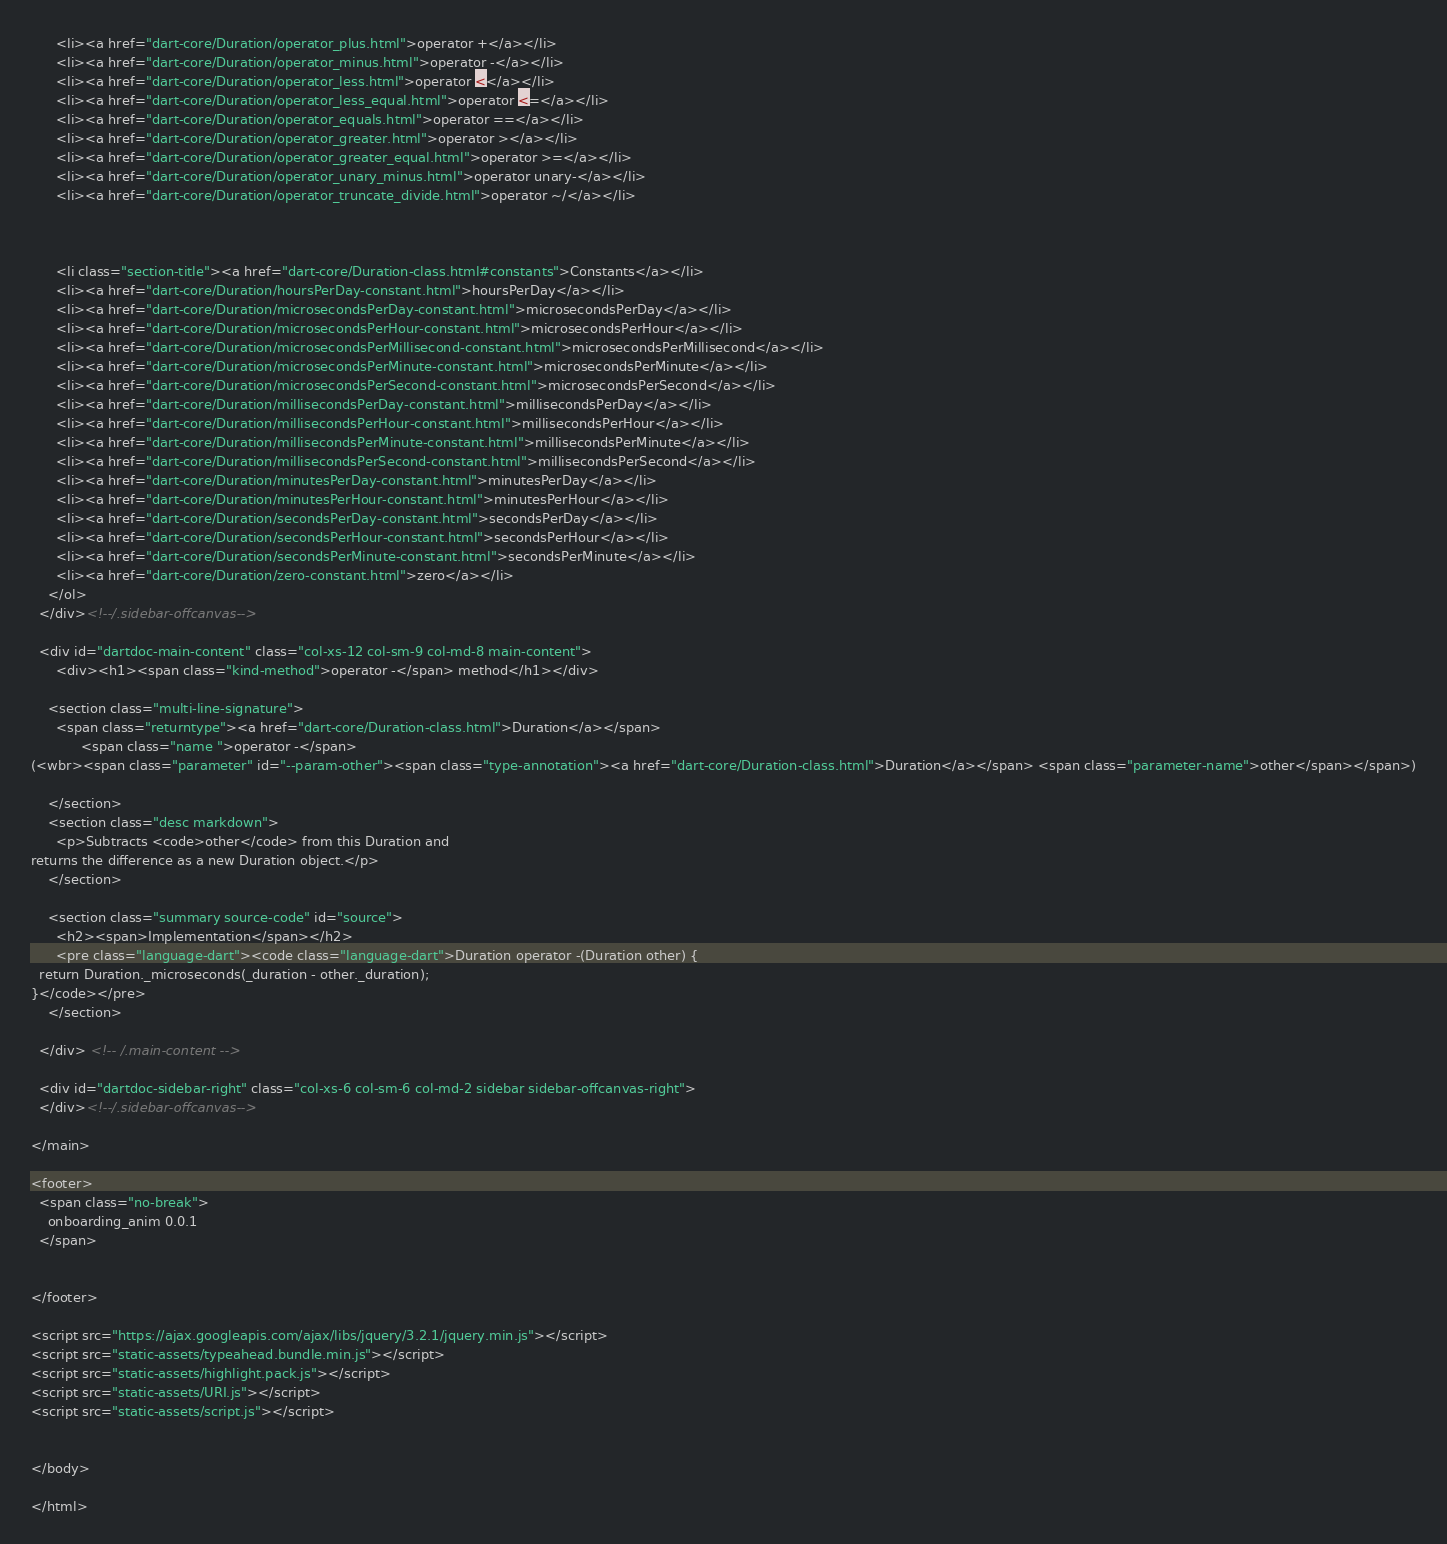<code> <loc_0><loc_0><loc_500><loc_500><_HTML_>      <li><a href="dart-core/Duration/operator_plus.html">operator +</a></li>
      <li><a href="dart-core/Duration/operator_minus.html">operator -</a></li>
      <li><a href="dart-core/Duration/operator_less.html">operator <</a></li>
      <li><a href="dart-core/Duration/operator_less_equal.html">operator <=</a></li>
      <li><a href="dart-core/Duration/operator_equals.html">operator ==</a></li>
      <li><a href="dart-core/Duration/operator_greater.html">operator ></a></li>
      <li><a href="dart-core/Duration/operator_greater_equal.html">operator >=</a></li>
      <li><a href="dart-core/Duration/operator_unary_minus.html">operator unary-</a></li>
      <li><a href="dart-core/Duration/operator_truncate_divide.html">operator ~/</a></li>
    
    
    
      <li class="section-title"><a href="dart-core/Duration-class.html#constants">Constants</a></li>
      <li><a href="dart-core/Duration/hoursPerDay-constant.html">hoursPerDay</a></li>
      <li><a href="dart-core/Duration/microsecondsPerDay-constant.html">microsecondsPerDay</a></li>
      <li><a href="dart-core/Duration/microsecondsPerHour-constant.html">microsecondsPerHour</a></li>
      <li><a href="dart-core/Duration/microsecondsPerMillisecond-constant.html">microsecondsPerMillisecond</a></li>
      <li><a href="dart-core/Duration/microsecondsPerMinute-constant.html">microsecondsPerMinute</a></li>
      <li><a href="dart-core/Duration/microsecondsPerSecond-constant.html">microsecondsPerSecond</a></li>
      <li><a href="dart-core/Duration/millisecondsPerDay-constant.html">millisecondsPerDay</a></li>
      <li><a href="dart-core/Duration/millisecondsPerHour-constant.html">millisecondsPerHour</a></li>
      <li><a href="dart-core/Duration/millisecondsPerMinute-constant.html">millisecondsPerMinute</a></li>
      <li><a href="dart-core/Duration/millisecondsPerSecond-constant.html">millisecondsPerSecond</a></li>
      <li><a href="dart-core/Duration/minutesPerDay-constant.html">minutesPerDay</a></li>
      <li><a href="dart-core/Duration/minutesPerHour-constant.html">minutesPerHour</a></li>
      <li><a href="dart-core/Duration/secondsPerDay-constant.html">secondsPerDay</a></li>
      <li><a href="dart-core/Duration/secondsPerHour-constant.html">secondsPerHour</a></li>
      <li><a href="dart-core/Duration/secondsPerMinute-constant.html">secondsPerMinute</a></li>
      <li><a href="dart-core/Duration/zero-constant.html">zero</a></li>
    </ol>
  </div><!--/.sidebar-offcanvas-->

  <div id="dartdoc-main-content" class="col-xs-12 col-sm-9 col-md-8 main-content">
      <div><h1><span class="kind-method">operator -</span> method</h1></div>

    <section class="multi-line-signature">
      <span class="returntype"><a href="dart-core/Duration-class.html">Duration</a></span>
            <span class="name ">operator -</span>
(<wbr><span class="parameter" id="--param-other"><span class="type-annotation"><a href="dart-core/Duration-class.html">Duration</a></span> <span class="parameter-name">other</span></span>)
      
    </section>
    <section class="desc markdown">
      <p>Subtracts <code>other</code> from this Duration and
returns the difference as a new Duration object.</p>
    </section>
    
    <section class="summary source-code" id="source">
      <h2><span>Implementation</span></h2>
      <pre class="language-dart"><code class="language-dart">Duration operator -(Duration other) {
  return Duration._microseconds(_duration - other._duration);
}</code></pre>
    </section>

  </div> <!-- /.main-content -->

  <div id="dartdoc-sidebar-right" class="col-xs-6 col-sm-6 col-md-2 sidebar sidebar-offcanvas-right">
  </div><!--/.sidebar-offcanvas-->

</main>

<footer>
  <span class="no-break">
    onboarding_anim 0.0.1
  </span>

  
</footer>

<script src="https://ajax.googleapis.com/ajax/libs/jquery/3.2.1/jquery.min.js"></script>
<script src="static-assets/typeahead.bundle.min.js"></script>
<script src="static-assets/highlight.pack.js"></script>
<script src="static-assets/URI.js"></script>
<script src="static-assets/script.js"></script>


</body>

</html>
</code> 